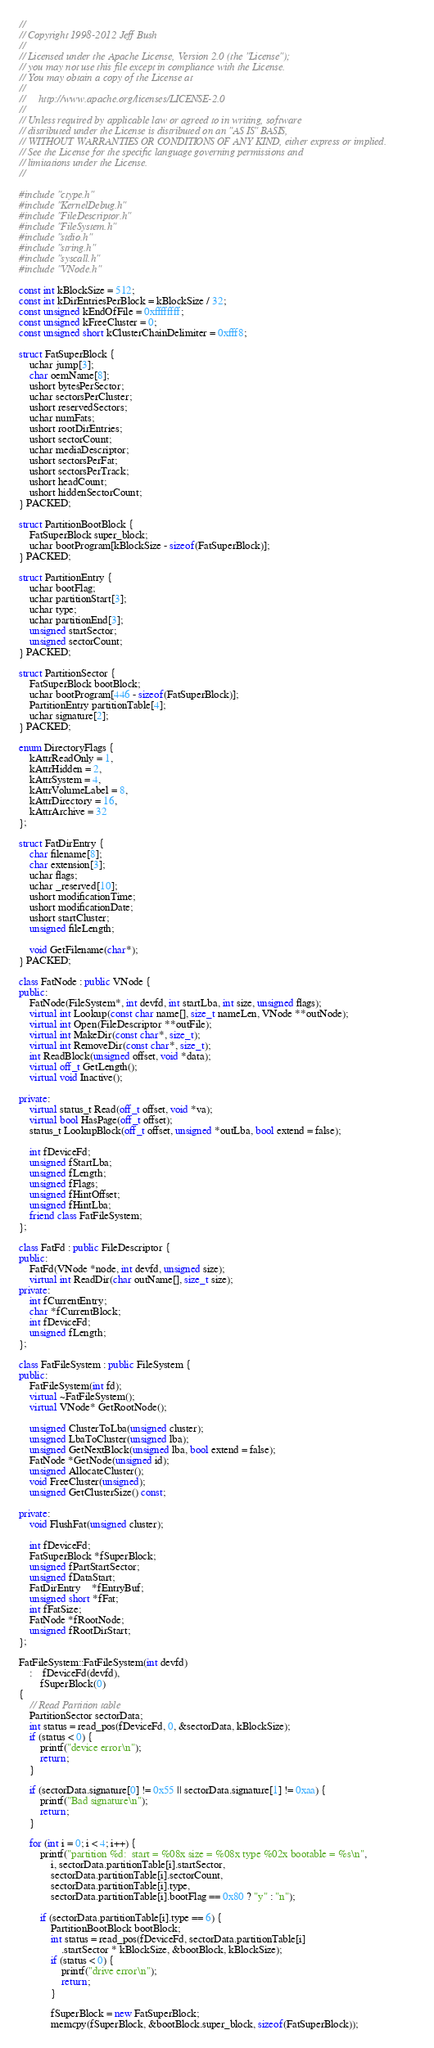<code> <loc_0><loc_0><loc_500><loc_500><_C++_>// 
// Copyright 1998-2012 Jeff Bush
// 
// Licensed under the Apache License, Version 2.0 (the "License");
// you may not use this file except in compliance with the License.
// You may obtain a copy of the License at
// 
//     http://www.apache.org/licenses/LICENSE-2.0
// 
// Unless required by applicable law or agreed to in writing, software
// distributed under the License is distributed on an "AS IS" BASIS,
// WITHOUT WARRANTIES OR CONDITIONS OF ANY KIND, either express or implied.
// See the License for the specific language governing permissions and
// limitations under the License.
// 

#include "ctype.h"
#include "KernelDebug.h"
#include "FileDescriptor.h"
#include "FileSystem.h"
#include "stdio.h"
#include "string.h"
#include "syscall.h"
#include "VNode.h"

const int kBlockSize = 512;
const int kDirEntriesPerBlock = kBlockSize / 32;
const unsigned kEndOfFile = 0xffffffff;
const unsigned kFreeCluster = 0;
const unsigned short kClusterChainDelimiter = 0xfff8;

struct FatSuperBlock {
	uchar jump[3];
	char oemName[8];
	ushort bytesPerSector;
	uchar sectorsPerCluster;
	ushort reservedSectors;
	uchar numFats;
	ushort rootDirEntries;
	ushort sectorCount;
	uchar mediaDescriptor;
	ushort sectorsPerFat;
	ushort sectorsPerTrack;
	ushort headCount;
	ushort hiddenSectorCount;
} PACKED;

struct PartitionBootBlock {
	FatSuperBlock super_block;
	uchar bootProgram[kBlockSize - sizeof(FatSuperBlock)];
} PACKED;

struct PartitionEntry {
	uchar bootFlag;
	uchar partitionStart[3];
	uchar type;
	uchar partitionEnd[3];
	unsigned startSector;
	unsigned sectorCount;
} PACKED;

struct PartitionSector {
	FatSuperBlock bootBlock;
	uchar bootProgram[446 - sizeof(FatSuperBlock)];
	PartitionEntry partitionTable[4];
	uchar signature[2];
} PACKED;

enum DirectoryFlags {
	kAttrReadOnly = 1,
	kAttrHidden = 2,
	kAttrSystem = 4,
	kAttrVolumeLabel = 8,
	kAttrDirectory = 16,
	kAttrArchive = 32	
};

struct FatDirEntry {
	char filename[8];
	char extension[3];
	uchar flags;
	uchar _reserved[10];
	ushort modificationTime;
	ushort modificationDate;
	ushort startCluster;
	unsigned fileLength;

	void GetFilename(char*);
} PACKED;

class FatNode : public VNode {
public:
	FatNode(FileSystem*, int devfd, int startLba, int size, unsigned flags);
	virtual int Lookup(const char name[], size_t nameLen, VNode **outNode);
	virtual int Open(FileDescriptor **outFile);
	virtual int MakeDir(const char*, size_t);
	virtual int RemoveDir(const char*, size_t);
	int ReadBlock(unsigned offset, void *data);
	virtual off_t GetLength();
	virtual void Inactive();
	
private:
	virtual status_t Read(off_t offset, void *va);
	virtual bool HasPage(off_t offset);
	status_t LookupBlock(off_t offset, unsigned *outLba, bool extend = false);

	int fDeviceFd;
	unsigned fStartLba;
	unsigned fLength;
	unsigned fFlags;
	unsigned fHintOffset;
	unsigned fHintLba;
	friend class FatFileSystem;
};

class FatFd : public FileDescriptor {
public:
	FatFd(VNode *node, int devfd, unsigned size);
	virtual int ReadDir(char outName[], size_t size);
private:
	int fCurrentEntry;
	char *fCurrentBlock;
	int fDeviceFd;
	unsigned fLength;
};

class FatFileSystem : public FileSystem {
public:
	FatFileSystem(int fd);
	virtual ~FatFileSystem();
	virtual VNode* GetRootNode();

	unsigned ClusterToLba(unsigned cluster);
	unsigned LbaToCluster(unsigned lba);
	unsigned GetNextBlock(unsigned lba, bool extend = false);
	FatNode *GetNode(unsigned id);
	unsigned AllocateCluster();
	void FreeCluster(unsigned);
	unsigned GetClusterSize() const;

private:
	void FlushFat(unsigned cluster);
	
	int fDeviceFd;
	FatSuperBlock *fSuperBlock;
	unsigned fPartStartSector;
	unsigned fDataStart;
	FatDirEntry	*fEntryBuf;
	unsigned short *fFat;
	int fFatSize;
	FatNode *fRootNode;
	unsigned fRootDirStart;
};

FatFileSystem::FatFileSystem(int devfd)
	:	fDeviceFd(devfd),
		fSuperBlock(0)
{
	// Read Partition table
	PartitionSector sectorData;
	int status = read_pos(fDeviceFd, 0, &sectorData, kBlockSize);
	if (status < 0) {
		printf("device error\n");
		return;
	}
	
	if (sectorData.signature[0] != 0x55 || sectorData.signature[1] != 0xaa) {
		printf("Bad signature\n");
		return;
	}
		
	for (int i = 0; i < 4; i++) {
		printf("partition %d:  start = %08x size = %08x type %02x bootable = %s\n",
			i, sectorData.partitionTable[i].startSector,
			sectorData.partitionTable[i].sectorCount,
			sectorData.partitionTable[i].type,
			sectorData.partitionTable[i].bootFlag == 0x80 ? "y" : "n");

		if (sectorData.partitionTable[i].type == 6) {
			PartitionBootBlock bootBlock;
			int status = read_pos(fDeviceFd, sectorData.partitionTable[i]
				.startSector * kBlockSize, &bootBlock, kBlockSize);
			if (status < 0) {
				printf("drive error\n");
				return;
			}
			
			fSuperBlock = new FatSuperBlock;
			memcpy(fSuperBlock, &bootBlock.super_block, sizeof(FatSuperBlock));</code> 